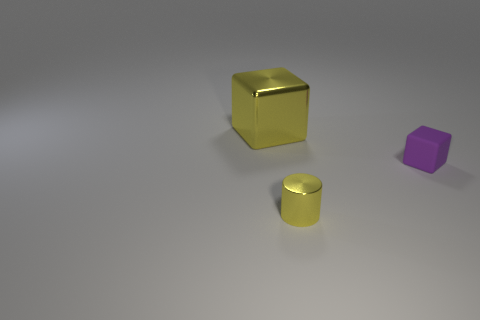How many large blue matte spheres are there?
Make the answer very short. 0. There is a rubber object; what shape is it?
Make the answer very short. Cube. How many purple objects have the same size as the metal cylinder?
Provide a short and direct response. 1. Is the tiny rubber object the same shape as the big yellow metal thing?
Make the answer very short. Yes. There is a block right of the yellow thing that is left of the yellow metallic cylinder; what color is it?
Make the answer very short. Purple. What is the size of the object that is both in front of the large cube and left of the small block?
Provide a short and direct response. Small. Are there any other things of the same color as the matte object?
Give a very brief answer. No. There is a yellow object that is the same material as the yellow cylinder; what is its shape?
Provide a short and direct response. Cube. There is a tiny metallic object; does it have the same shape as the metal object that is behind the small purple rubber block?
Make the answer very short. No. There is a block to the right of the yellow metal cylinder in front of the rubber block; what is it made of?
Provide a short and direct response. Rubber. 